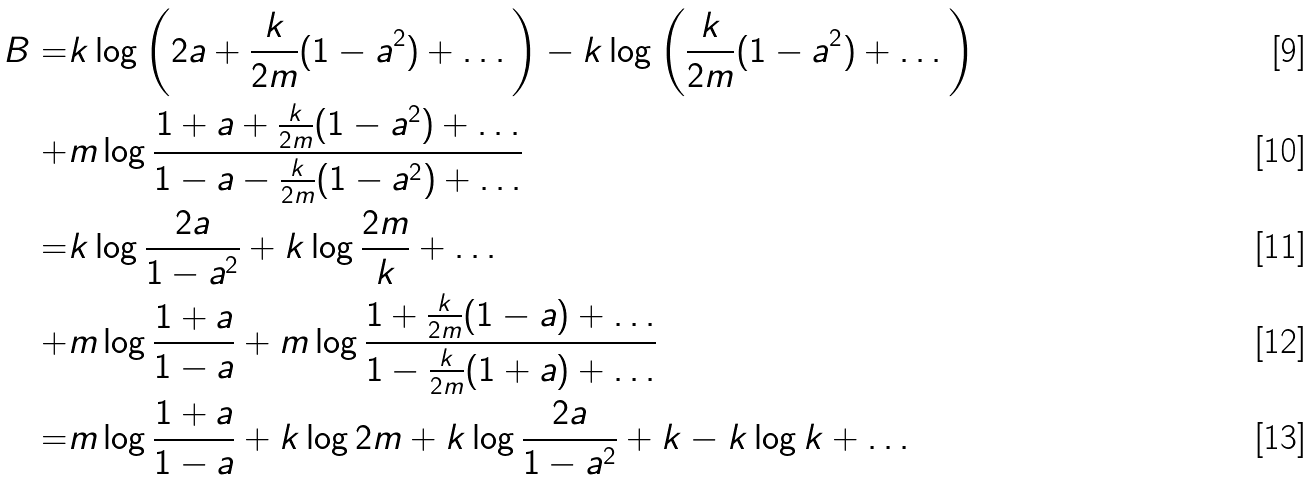Convert formula to latex. <formula><loc_0><loc_0><loc_500><loc_500>B = & k \log \left ( 2 a + \frac { k } { 2 m } ( 1 - a ^ { 2 } ) + \dots \right ) - k \log \left ( \frac { k } { 2 m } ( 1 - a ^ { 2 } ) + \dots \right ) \\ + & m \log \frac { 1 + a + \frac { k } { 2 m } ( 1 - a ^ { 2 } ) + \dots } { 1 - a - \frac { k } { 2 m } ( 1 - a ^ { 2 } ) + \dots } \\ = & k \log \frac { 2 a } { 1 - a ^ { 2 } } + k \log \frac { 2 m } { k } + \dots \\ + & m \log \frac { 1 + a } { 1 - a } + m \log \frac { 1 + \frac { k } { 2 m } ( 1 - a ) + \dots } { 1 - \frac { k } { 2 m } ( 1 + a ) + \dots } \\ = & m \log \frac { 1 + a } { 1 - a } + k \log { 2 m } + k \log \frac { 2 a } { 1 - a ^ { 2 } } + k - k \log k + \dots</formula> 